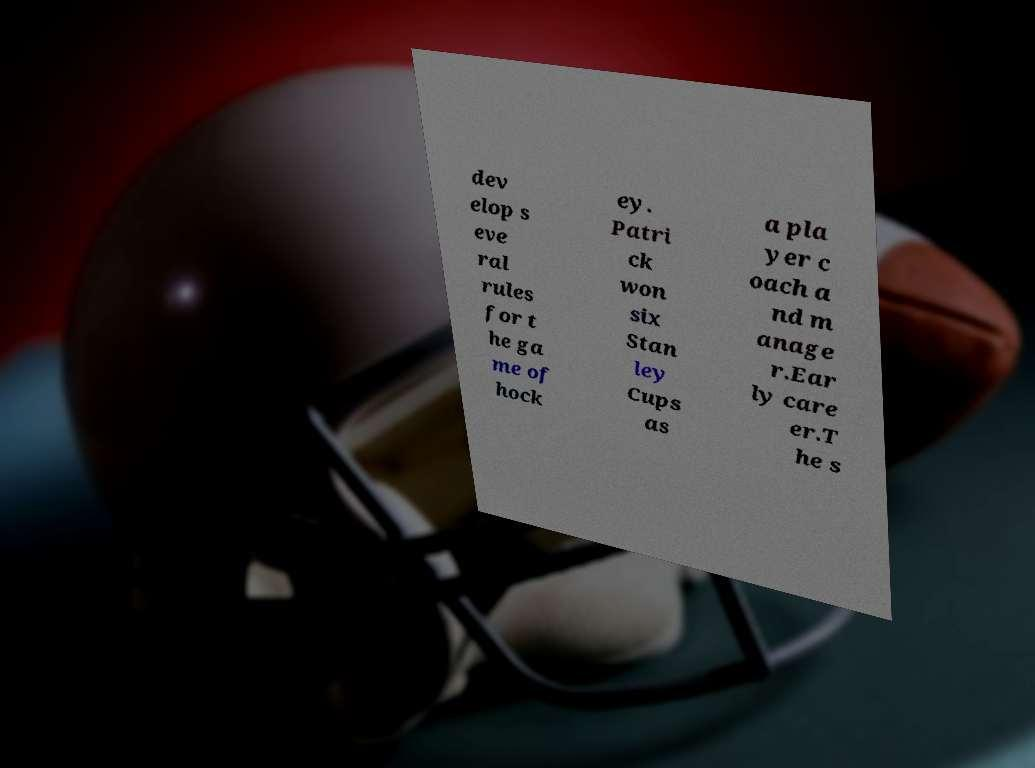Could you extract and type out the text from this image? dev elop s eve ral rules for t he ga me of hock ey. Patri ck won six Stan ley Cups as a pla yer c oach a nd m anage r.Ear ly care er.T he s 